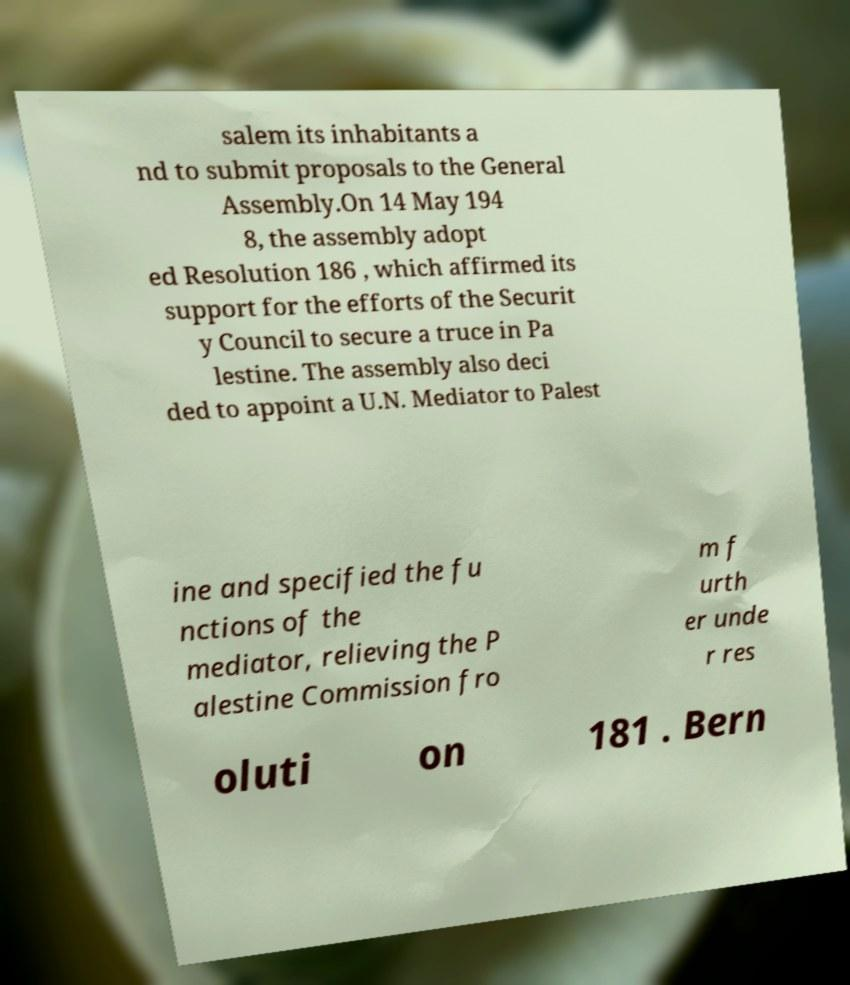Could you assist in decoding the text presented in this image and type it out clearly? salem its inhabitants a nd to submit proposals to the General Assembly.On 14 May 194 8, the assembly adopt ed Resolution 186 , which affirmed its support for the efforts of the Securit y Council to secure a truce in Pa lestine. The assembly also deci ded to appoint a U.N. Mediator to Palest ine and specified the fu nctions of the mediator, relieving the P alestine Commission fro m f urth er unde r res oluti on 181 . Bern 